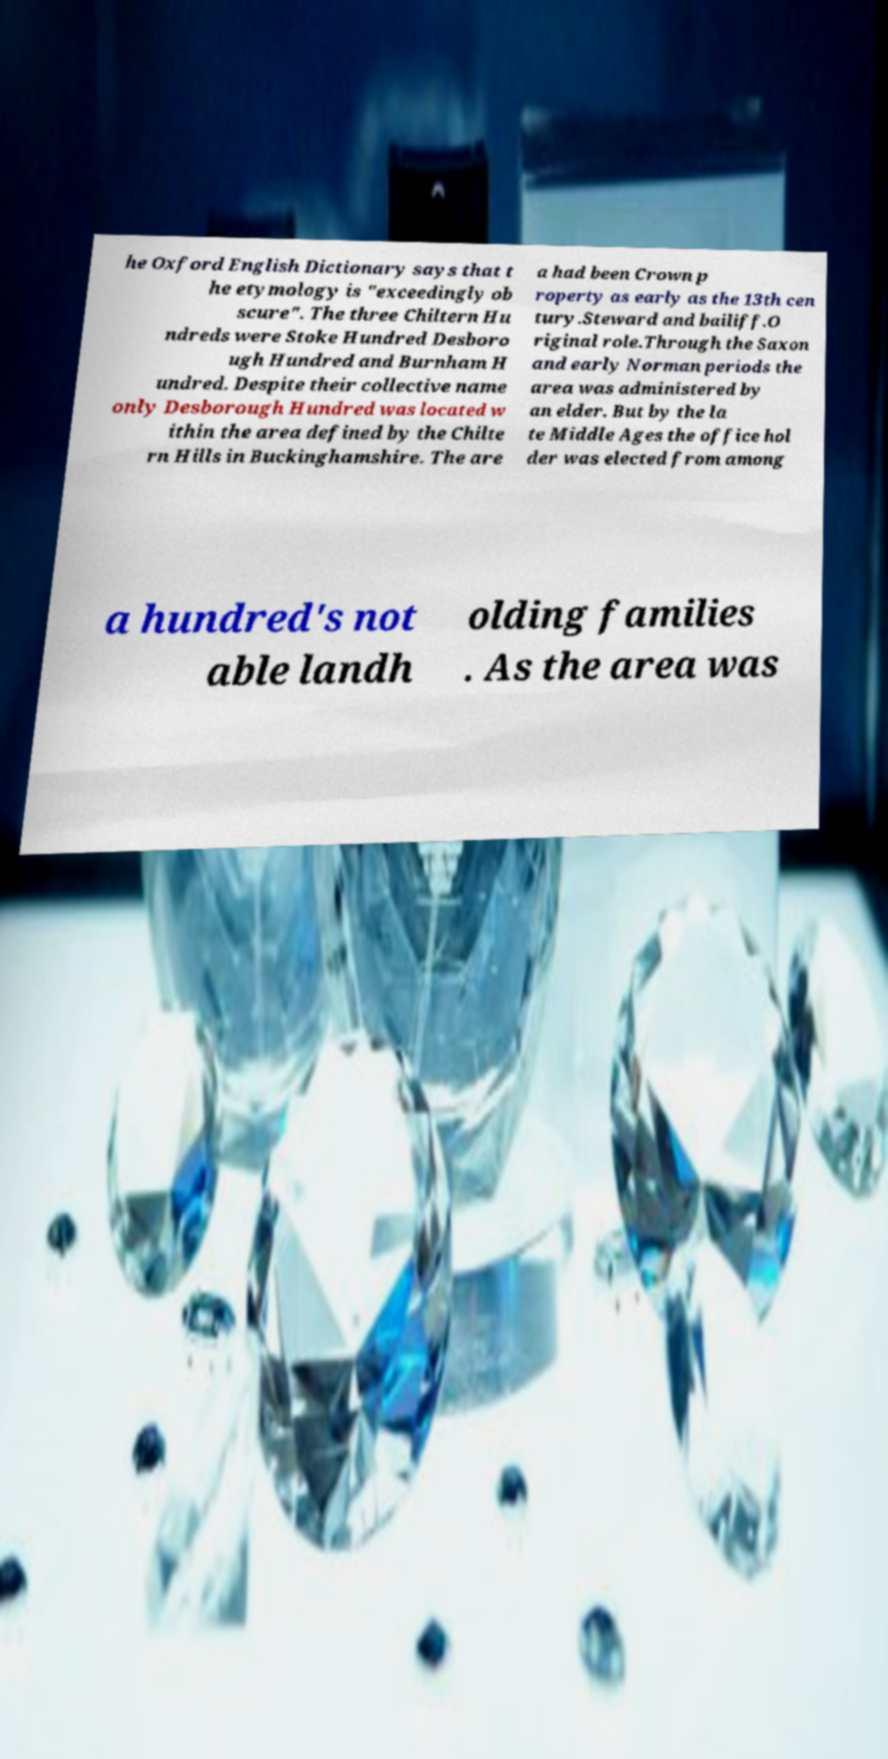Please identify and transcribe the text found in this image. he Oxford English Dictionary says that t he etymology is "exceedingly ob scure". The three Chiltern Hu ndreds were Stoke Hundred Desboro ugh Hundred and Burnham H undred. Despite their collective name only Desborough Hundred was located w ithin the area defined by the Chilte rn Hills in Buckinghamshire. The are a had been Crown p roperty as early as the 13th cen tury.Steward and bailiff.O riginal role.Through the Saxon and early Norman periods the area was administered by an elder. But by the la te Middle Ages the office hol der was elected from among a hundred's not able landh olding families . As the area was 